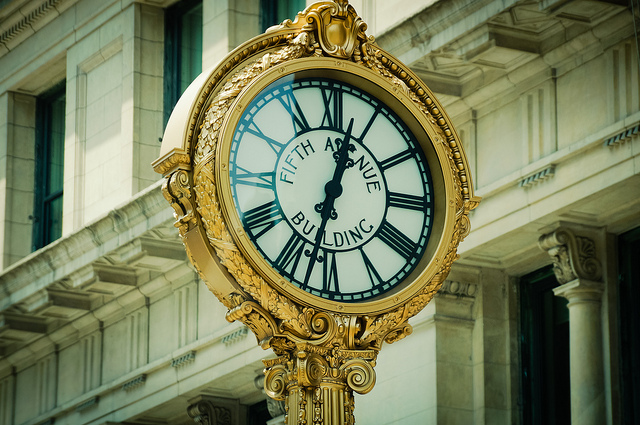Please identify all text content in this image. FIFTH III BUILDING ANUE III XI 